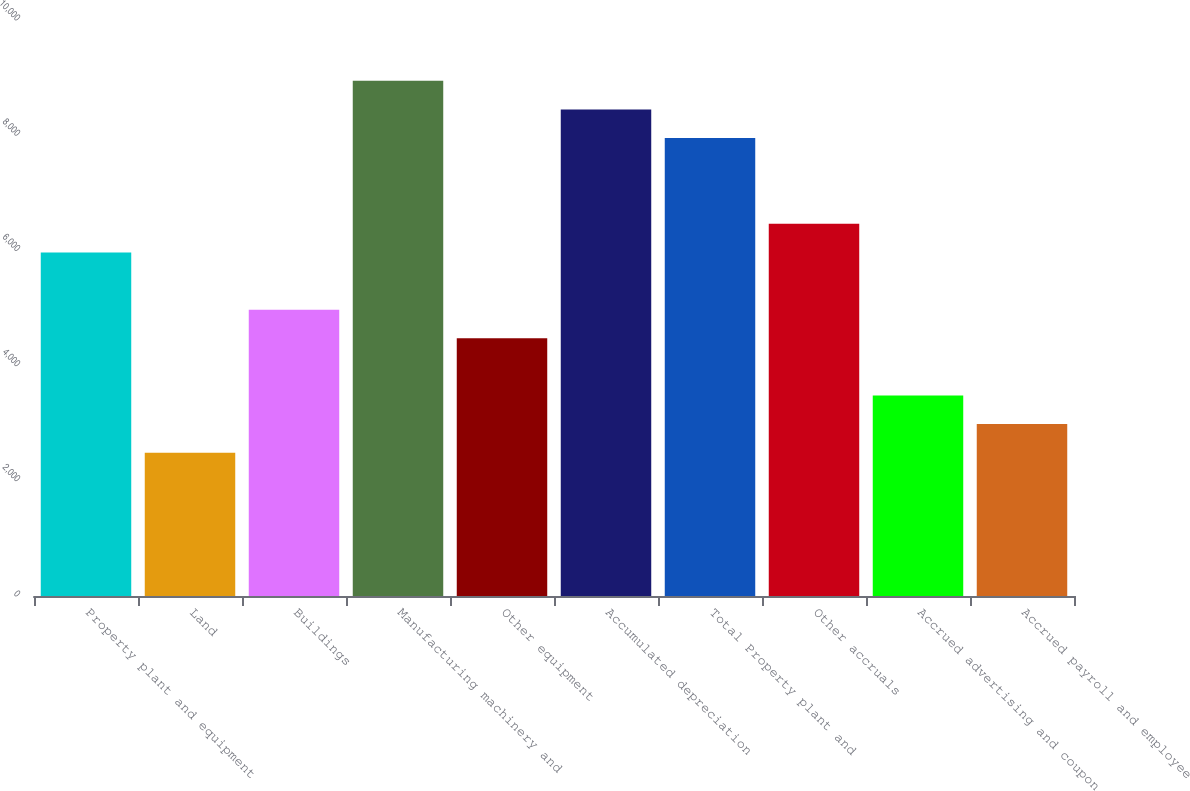Convert chart to OTSL. <chart><loc_0><loc_0><loc_500><loc_500><bar_chart><fcel>Property plant and equipment<fcel>Land<fcel>Buildings<fcel>Manufacturing machinery and<fcel>Other equipment<fcel>Accumulated depreciation<fcel>Total Property plant and<fcel>Other accruals<fcel>Accrued advertising and coupon<fcel>Accrued payroll and employee<nl><fcel>5964.4<fcel>2487.5<fcel>4971<fcel>8944.6<fcel>4474.3<fcel>8447.9<fcel>7951.2<fcel>6461.1<fcel>3480.9<fcel>2984.2<nl></chart> 